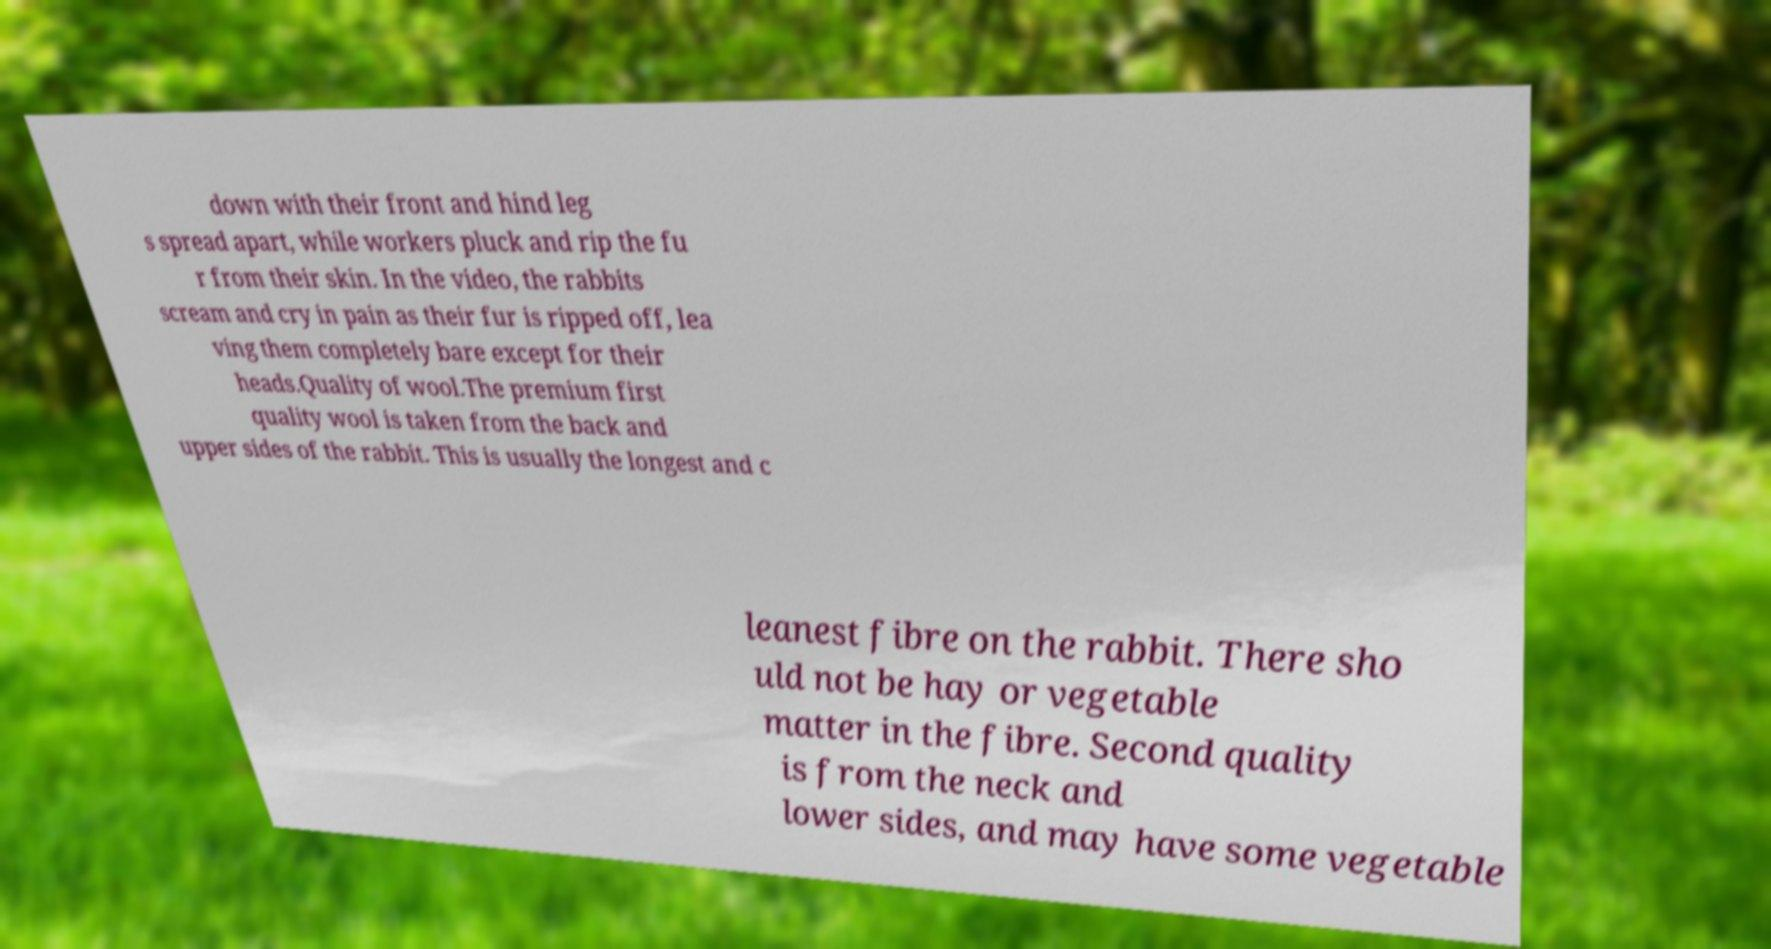Could you assist in decoding the text presented in this image and type it out clearly? down with their front and hind leg s spread apart, while workers pluck and rip the fu r from their skin. In the video, the rabbits scream and cry in pain as their fur is ripped off, lea ving them completely bare except for their heads.Quality of wool.The premium first quality wool is taken from the back and upper sides of the rabbit. This is usually the longest and c leanest fibre on the rabbit. There sho uld not be hay or vegetable matter in the fibre. Second quality is from the neck and lower sides, and may have some vegetable 